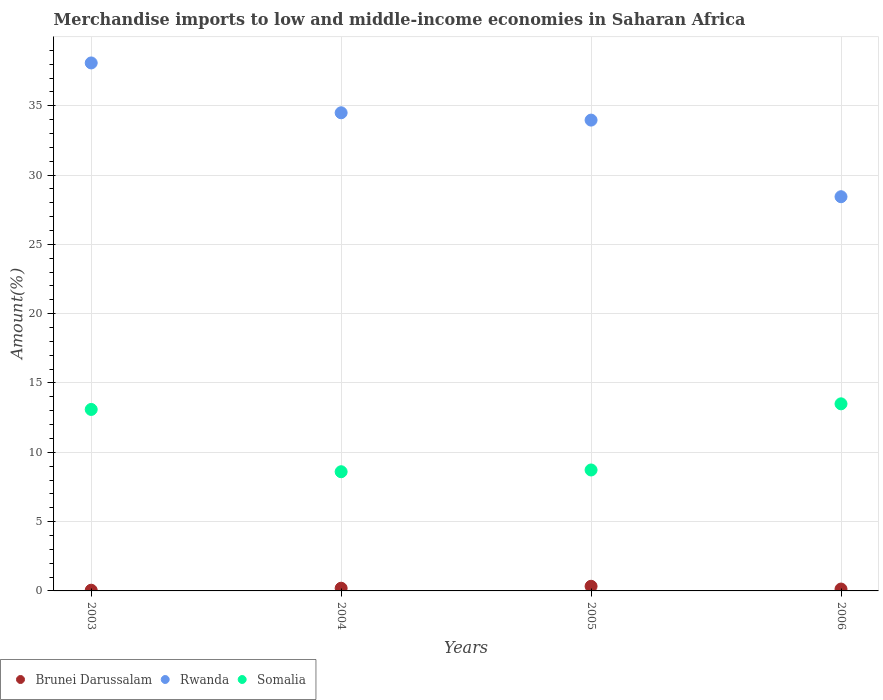How many different coloured dotlines are there?
Make the answer very short. 3. Is the number of dotlines equal to the number of legend labels?
Ensure brevity in your answer.  Yes. What is the percentage of amount earned from merchandise imports in Somalia in 2006?
Your answer should be compact. 13.5. Across all years, what is the maximum percentage of amount earned from merchandise imports in Somalia?
Offer a very short reply. 13.5. Across all years, what is the minimum percentage of amount earned from merchandise imports in Rwanda?
Make the answer very short. 28.44. In which year was the percentage of amount earned from merchandise imports in Rwanda maximum?
Your response must be concise. 2003. In which year was the percentage of amount earned from merchandise imports in Rwanda minimum?
Ensure brevity in your answer.  2006. What is the total percentage of amount earned from merchandise imports in Somalia in the graph?
Your response must be concise. 43.91. What is the difference between the percentage of amount earned from merchandise imports in Rwanda in 2003 and that in 2006?
Offer a very short reply. 9.65. What is the difference between the percentage of amount earned from merchandise imports in Somalia in 2006 and the percentage of amount earned from merchandise imports in Brunei Darussalam in 2003?
Provide a short and direct response. 13.45. What is the average percentage of amount earned from merchandise imports in Brunei Darussalam per year?
Offer a very short reply. 0.18. In the year 2005, what is the difference between the percentage of amount earned from merchandise imports in Rwanda and percentage of amount earned from merchandise imports in Brunei Darussalam?
Offer a very short reply. 33.63. What is the ratio of the percentage of amount earned from merchandise imports in Somalia in 2003 to that in 2004?
Give a very brief answer. 1.52. What is the difference between the highest and the second highest percentage of amount earned from merchandise imports in Rwanda?
Offer a very short reply. 3.6. What is the difference between the highest and the lowest percentage of amount earned from merchandise imports in Rwanda?
Provide a short and direct response. 9.65. Is the sum of the percentage of amount earned from merchandise imports in Somalia in 2003 and 2005 greater than the maximum percentage of amount earned from merchandise imports in Brunei Darussalam across all years?
Ensure brevity in your answer.  Yes. Does the percentage of amount earned from merchandise imports in Rwanda monotonically increase over the years?
Your answer should be compact. No. How many years are there in the graph?
Provide a succinct answer. 4. Does the graph contain any zero values?
Provide a succinct answer. No. What is the title of the graph?
Offer a very short reply. Merchandise imports to low and middle-income economies in Saharan Africa. What is the label or title of the X-axis?
Ensure brevity in your answer.  Years. What is the label or title of the Y-axis?
Offer a terse response. Amount(%). What is the Amount(%) in Brunei Darussalam in 2003?
Offer a very short reply. 0.05. What is the Amount(%) of Rwanda in 2003?
Keep it short and to the point. 38.09. What is the Amount(%) in Somalia in 2003?
Keep it short and to the point. 13.09. What is the Amount(%) in Brunei Darussalam in 2004?
Offer a terse response. 0.19. What is the Amount(%) of Rwanda in 2004?
Keep it short and to the point. 34.49. What is the Amount(%) in Somalia in 2004?
Make the answer very short. 8.6. What is the Amount(%) in Brunei Darussalam in 2005?
Your response must be concise. 0.33. What is the Amount(%) in Rwanda in 2005?
Your answer should be compact. 33.97. What is the Amount(%) of Somalia in 2005?
Make the answer very short. 8.73. What is the Amount(%) of Brunei Darussalam in 2006?
Offer a terse response. 0.14. What is the Amount(%) of Rwanda in 2006?
Provide a short and direct response. 28.44. What is the Amount(%) in Somalia in 2006?
Make the answer very short. 13.5. Across all years, what is the maximum Amount(%) in Brunei Darussalam?
Offer a very short reply. 0.33. Across all years, what is the maximum Amount(%) in Rwanda?
Your answer should be very brief. 38.09. Across all years, what is the maximum Amount(%) of Somalia?
Provide a short and direct response. 13.5. Across all years, what is the minimum Amount(%) of Brunei Darussalam?
Keep it short and to the point. 0.05. Across all years, what is the minimum Amount(%) in Rwanda?
Make the answer very short. 28.44. Across all years, what is the minimum Amount(%) of Somalia?
Offer a terse response. 8.6. What is the total Amount(%) of Brunei Darussalam in the graph?
Offer a terse response. 0.71. What is the total Amount(%) in Rwanda in the graph?
Offer a very short reply. 134.99. What is the total Amount(%) in Somalia in the graph?
Give a very brief answer. 43.91. What is the difference between the Amount(%) in Brunei Darussalam in 2003 and that in 2004?
Your response must be concise. -0.14. What is the difference between the Amount(%) of Rwanda in 2003 and that in 2004?
Provide a short and direct response. 3.6. What is the difference between the Amount(%) of Somalia in 2003 and that in 2004?
Ensure brevity in your answer.  4.49. What is the difference between the Amount(%) in Brunei Darussalam in 2003 and that in 2005?
Offer a terse response. -0.28. What is the difference between the Amount(%) in Rwanda in 2003 and that in 2005?
Offer a very short reply. 4.12. What is the difference between the Amount(%) in Somalia in 2003 and that in 2005?
Your answer should be compact. 4.37. What is the difference between the Amount(%) of Brunei Darussalam in 2003 and that in 2006?
Provide a succinct answer. -0.08. What is the difference between the Amount(%) of Rwanda in 2003 and that in 2006?
Your response must be concise. 9.65. What is the difference between the Amount(%) of Somalia in 2003 and that in 2006?
Ensure brevity in your answer.  -0.41. What is the difference between the Amount(%) in Brunei Darussalam in 2004 and that in 2005?
Keep it short and to the point. -0.14. What is the difference between the Amount(%) in Rwanda in 2004 and that in 2005?
Provide a short and direct response. 0.53. What is the difference between the Amount(%) of Somalia in 2004 and that in 2005?
Provide a succinct answer. -0.13. What is the difference between the Amount(%) in Brunei Darussalam in 2004 and that in 2006?
Offer a very short reply. 0.06. What is the difference between the Amount(%) of Rwanda in 2004 and that in 2006?
Your answer should be very brief. 6.06. What is the difference between the Amount(%) in Somalia in 2004 and that in 2006?
Provide a short and direct response. -4.9. What is the difference between the Amount(%) in Brunei Darussalam in 2005 and that in 2006?
Make the answer very short. 0.2. What is the difference between the Amount(%) in Rwanda in 2005 and that in 2006?
Make the answer very short. 5.53. What is the difference between the Amount(%) in Somalia in 2005 and that in 2006?
Make the answer very short. -4.77. What is the difference between the Amount(%) in Brunei Darussalam in 2003 and the Amount(%) in Rwanda in 2004?
Your response must be concise. -34.44. What is the difference between the Amount(%) of Brunei Darussalam in 2003 and the Amount(%) of Somalia in 2004?
Give a very brief answer. -8.55. What is the difference between the Amount(%) in Rwanda in 2003 and the Amount(%) in Somalia in 2004?
Give a very brief answer. 29.49. What is the difference between the Amount(%) in Brunei Darussalam in 2003 and the Amount(%) in Rwanda in 2005?
Make the answer very short. -33.91. What is the difference between the Amount(%) in Brunei Darussalam in 2003 and the Amount(%) in Somalia in 2005?
Your response must be concise. -8.67. What is the difference between the Amount(%) in Rwanda in 2003 and the Amount(%) in Somalia in 2005?
Offer a very short reply. 29.36. What is the difference between the Amount(%) in Brunei Darussalam in 2003 and the Amount(%) in Rwanda in 2006?
Make the answer very short. -28.39. What is the difference between the Amount(%) in Brunei Darussalam in 2003 and the Amount(%) in Somalia in 2006?
Your answer should be very brief. -13.45. What is the difference between the Amount(%) in Rwanda in 2003 and the Amount(%) in Somalia in 2006?
Your answer should be very brief. 24.59. What is the difference between the Amount(%) of Brunei Darussalam in 2004 and the Amount(%) of Rwanda in 2005?
Your answer should be very brief. -33.77. What is the difference between the Amount(%) of Brunei Darussalam in 2004 and the Amount(%) of Somalia in 2005?
Provide a succinct answer. -8.53. What is the difference between the Amount(%) in Rwanda in 2004 and the Amount(%) in Somalia in 2005?
Your response must be concise. 25.77. What is the difference between the Amount(%) of Brunei Darussalam in 2004 and the Amount(%) of Rwanda in 2006?
Your answer should be compact. -28.24. What is the difference between the Amount(%) of Brunei Darussalam in 2004 and the Amount(%) of Somalia in 2006?
Provide a succinct answer. -13.3. What is the difference between the Amount(%) in Rwanda in 2004 and the Amount(%) in Somalia in 2006?
Ensure brevity in your answer.  21. What is the difference between the Amount(%) of Brunei Darussalam in 2005 and the Amount(%) of Rwanda in 2006?
Make the answer very short. -28.1. What is the difference between the Amount(%) of Brunei Darussalam in 2005 and the Amount(%) of Somalia in 2006?
Ensure brevity in your answer.  -13.16. What is the difference between the Amount(%) of Rwanda in 2005 and the Amount(%) of Somalia in 2006?
Offer a terse response. 20.47. What is the average Amount(%) of Brunei Darussalam per year?
Your response must be concise. 0.18. What is the average Amount(%) of Rwanda per year?
Your response must be concise. 33.75. What is the average Amount(%) of Somalia per year?
Offer a very short reply. 10.98. In the year 2003, what is the difference between the Amount(%) in Brunei Darussalam and Amount(%) in Rwanda?
Provide a succinct answer. -38.04. In the year 2003, what is the difference between the Amount(%) of Brunei Darussalam and Amount(%) of Somalia?
Provide a short and direct response. -13.04. In the year 2003, what is the difference between the Amount(%) in Rwanda and Amount(%) in Somalia?
Give a very brief answer. 25. In the year 2004, what is the difference between the Amount(%) of Brunei Darussalam and Amount(%) of Rwanda?
Ensure brevity in your answer.  -34.3. In the year 2004, what is the difference between the Amount(%) in Brunei Darussalam and Amount(%) in Somalia?
Ensure brevity in your answer.  -8.4. In the year 2004, what is the difference between the Amount(%) in Rwanda and Amount(%) in Somalia?
Your response must be concise. 25.9. In the year 2005, what is the difference between the Amount(%) of Brunei Darussalam and Amount(%) of Rwanda?
Your answer should be compact. -33.63. In the year 2005, what is the difference between the Amount(%) of Brunei Darussalam and Amount(%) of Somalia?
Provide a short and direct response. -8.39. In the year 2005, what is the difference between the Amount(%) of Rwanda and Amount(%) of Somalia?
Keep it short and to the point. 25.24. In the year 2006, what is the difference between the Amount(%) in Brunei Darussalam and Amount(%) in Rwanda?
Keep it short and to the point. -28.3. In the year 2006, what is the difference between the Amount(%) of Brunei Darussalam and Amount(%) of Somalia?
Give a very brief answer. -13.36. In the year 2006, what is the difference between the Amount(%) in Rwanda and Amount(%) in Somalia?
Your answer should be compact. 14.94. What is the ratio of the Amount(%) in Brunei Darussalam in 2003 to that in 2004?
Offer a terse response. 0.26. What is the ratio of the Amount(%) of Rwanda in 2003 to that in 2004?
Offer a terse response. 1.1. What is the ratio of the Amount(%) of Somalia in 2003 to that in 2004?
Make the answer very short. 1.52. What is the ratio of the Amount(%) of Brunei Darussalam in 2003 to that in 2005?
Give a very brief answer. 0.15. What is the ratio of the Amount(%) in Rwanda in 2003 to that in 2005?
Provide a succinct answer. 1.12. What is the ratio of the Amount(%) in Somalia in 2003 to that in 2005?
Give a very brief answer. 1.5. What is the ratio of the Amount(%) in Brunei Darussalam in 2003 to that in 2006?
Offer a very short reply. 0.38. What is the ratio of the Amount(%) in Rwanda in 2003 to that in 2006?
Keep it short and to the point. 1.34. What is the ratio of the Amount(%) of Somalia in 2003 to that in 2006?
Offer a very short reply. 0.97. What is the ratio of the Amount(%) in Brunei Darussalam in 2004 to that in 2005?
Ensure brevity in your answer.  0.58. What is the ratio of the Amount(%) of Rwanda in 2004 to that in 2005?
Make the answer very short. 1.02. What is the ratio of the Amount(%) of Somalia in 2004 to that in 2005?
Provide a short and direct response. 0.99. What is the ratio of the Amount(%) of Brunei Darussalam in 2004 to that in 2006?
Provide a short and direct response. 1.44. What is the ratio of the Amount(%) of Rwanda in 2004 to that in 2006?
Offer a very short reply. 1.21. What is the ratio of the Amount(%) of Somalia in 2004 to that in 2006?
Make the answer very short. 0.64. What is the ratio of the Amount(%) of Brunei Darussalam in 2005 to that in 2006?
Your answer should be compact. 2.48. What is the ratio of the Amount(%) in Rwanda in 2005 to that in 2006?
Make the answer very short. 1.19. What is the ratio of the Amount(%) of Somalia in 2005 to that in 2006?
Provide a short and direct response. 0.65. What is the difference between the highest and the second highest Amount(%) of Brunei Darussalam?
Keep it short and to the point. 0.14. What is the difference between the highest and the second highest Amount(%) of Rwanda?
Make the answer very short. 3.6. What is the difference between the highest and the second highest Amount(%) of Somalia?
Make the answer very short. 0.41. What is the difference between the highest and the lowest Amount(%) in Brunei Darussalam?
Provide a succinct answer. 0.28. What is the difference between the highest and the lowest Amount(%) of Rwanda?
Your answer should be compact. 9.65. What is the difference between the highest and the lowest Amount(%) in Somalia?
Your answer should be very brief. 4.9. 